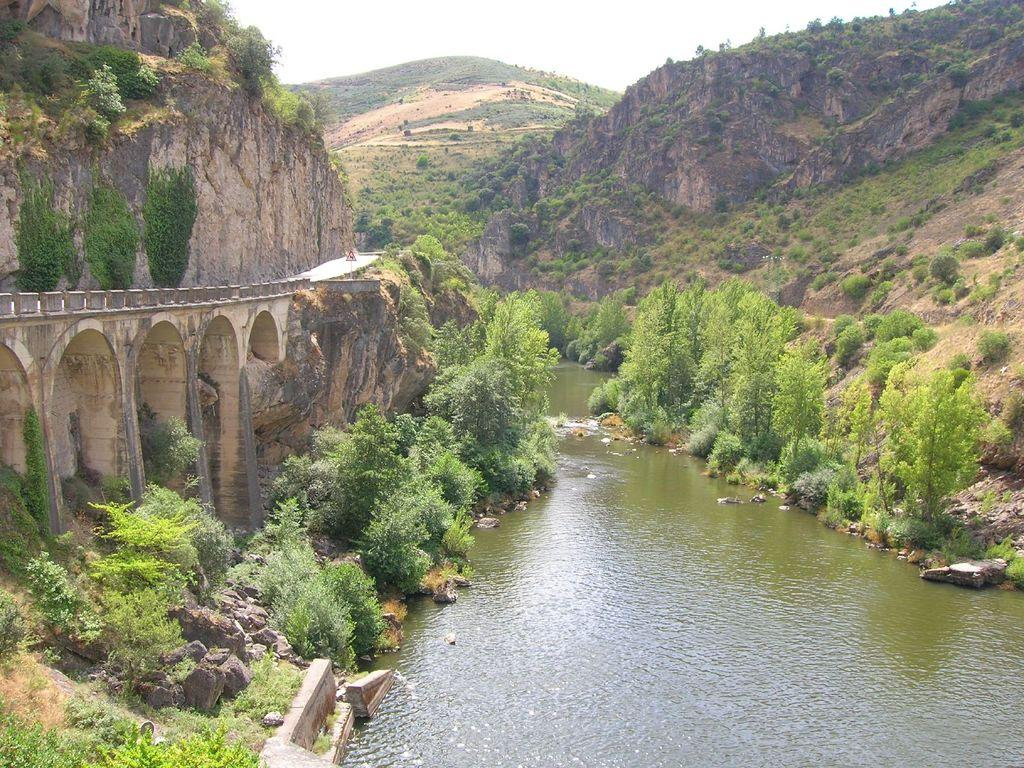What structure is located on the left side of the image? There is a bridge on the left side of the image. What type of natural features can be seen in the image? There are mountains, plants, trees, and water visible in the image. What part of the sky is visible in the image? The sky is visible at the top of the image. How many birds are in the flock flying over the mountains in the image? There is no flock of birds visible in the image; it features a bridge, mountains, plants, trees, water, and the sky. Can you describe the haircut of the trees in the image? There is no haircut associated with the trees in the image; they are simply trees with branches and leaves. 